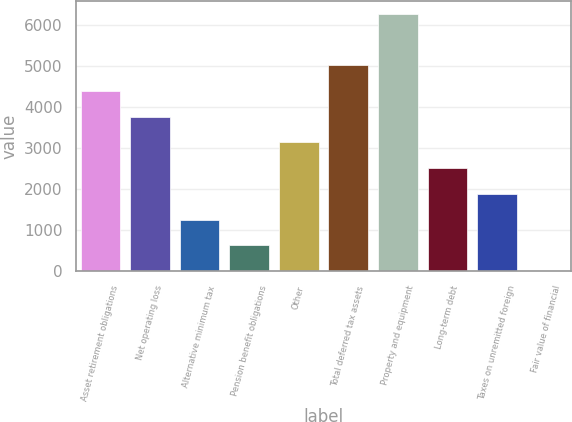Convert chart. <chart><loc_0><loc_0><loc_500><loc_500><bar_chart><fcel>Asset retirement obligations<fcel>Net operating loss<fcel>Alternative minimum tax<fcel>Pension benefit obligations<fcel>Other<fcel>Total deferred tax assets<fcel>Property and equipment<fcel>Long-term debt<fcel>Taxes on unremitted foreign<fcel>Fair value of financial<nl><fcel>4392.5<fcel>3766<fcel>1260<fcel>633.5<fcel>3139.5<fcel>5019<fcel>6272<fcel>2513<fcel>1886.5<fcel>7<nl></chart> 